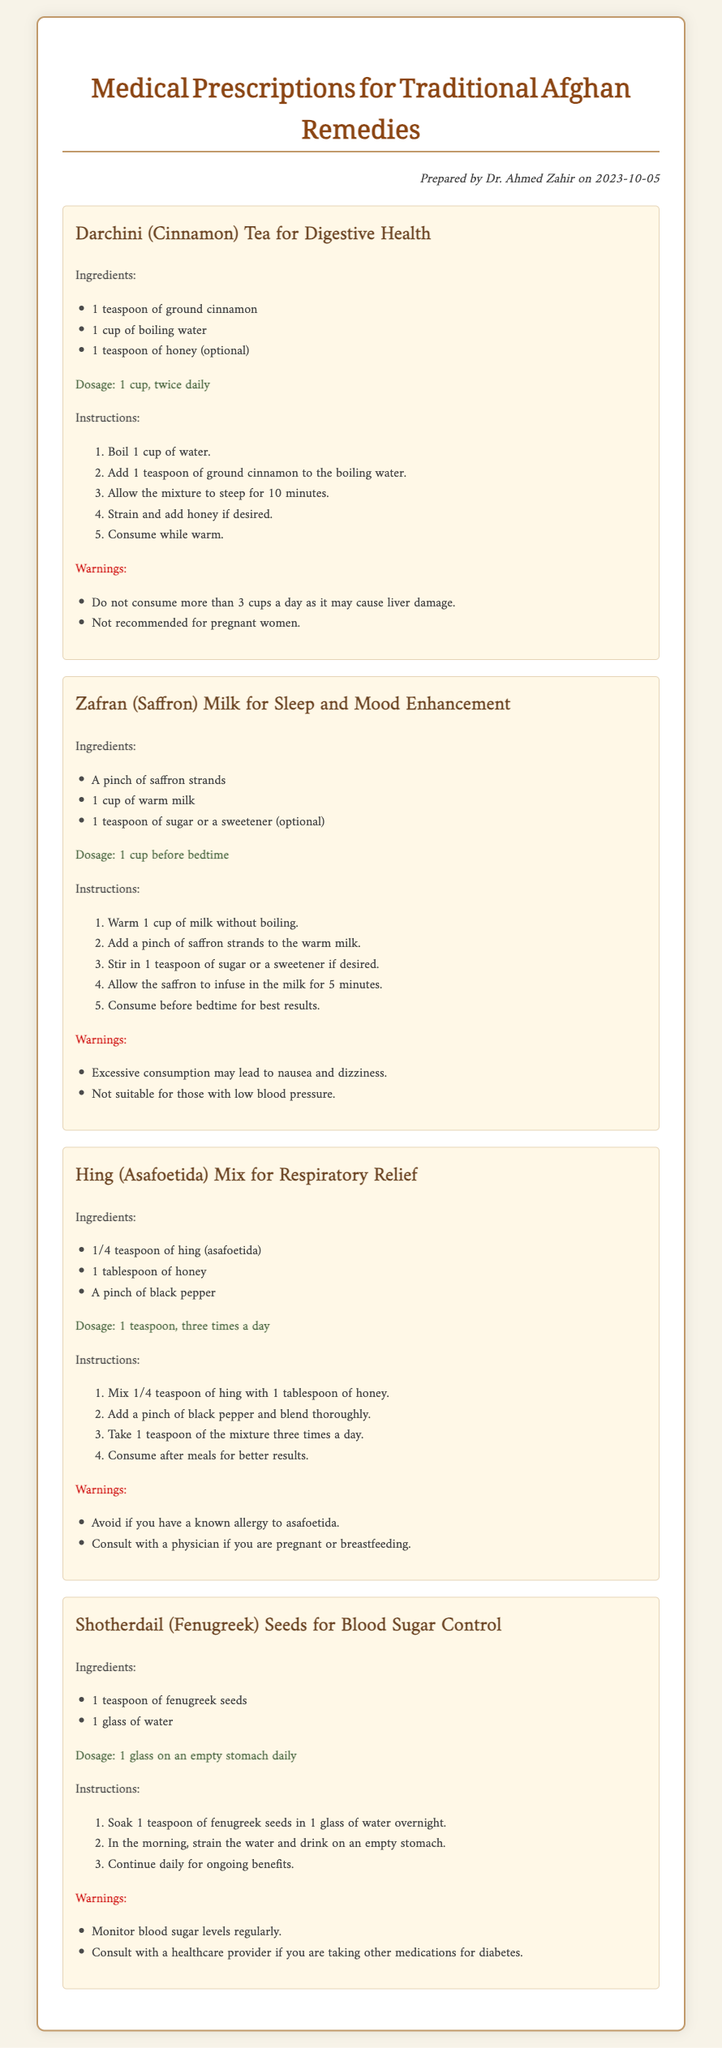What is the title of the document? The title of the document is presented in the heading at the top, indicating the subject matter.
Answer: Medical Prescriptions for Traditional Afghan Remedies Who prepared the document? The author's name is noted in the document's header, indicating who created the prescriptions.
Answer: Dr. Ahmed Zahir What is the dosage for Darchini Tea? The dosage is specifically mentioned for the Darchini remedy within the section detailing this remedy.
Answer: 1 cup, twice daily What ingredient is used for Zafran Milk? The ingredients are listed in a bullet format, identifying the key components of the remedy.
Answer: A pinch of saffron strands How often should Hing Mix be taken? The dosage section describes the frequency of intake for Hing Mix to ensure proper use.
Answer: three times a day What should be avoided when consuming Zafran Milk? The warnings section contains precautionary advice related to excessive consumption.
Answer: Excessive consumption may lead to nausea and dizziness What is the main purpose of Shotherdail seeds? The intended health benefit of the Shotherdail remedy is described in the title of this section.
Answer: Blood Sugar Control What should be done with fenugreek seeds overnight? The instructions provide a step-by-step guide, including the preparation required for the seeds.
Answer: Soak in water 